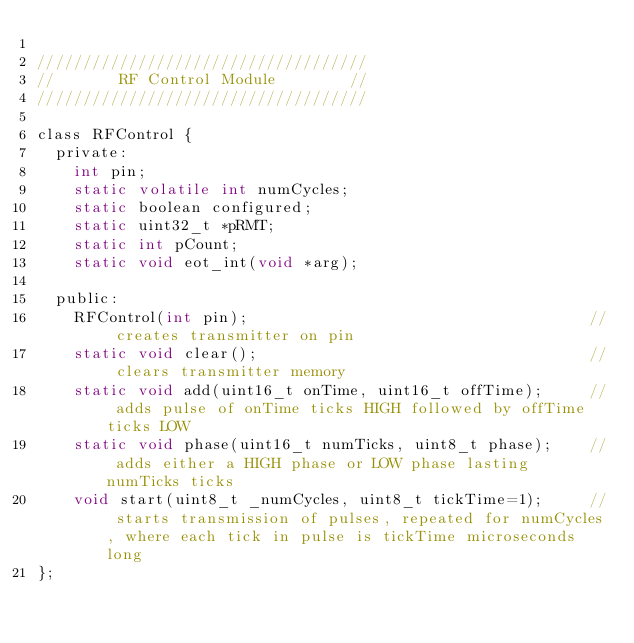<code> <loc_0><loc_0><loc_500><loc_500><_C_>
////////////////////////////////////
//       RF Control Module        //
////////////////////////////////////

class RFControl {
  private:
    int pin;
    static volatile int numCycles;
    static boolean configured;
    static uint32_t *pRMT;
    static int pCount;
    static void eot_int(void *arg);                         

  public:    
    RFControl(int pin);                                     // creates transmitter on pin
    static void clear();                                    // clears transmitter memory
    static void add(uint16_t onTime, uint16_t offTime);     // adds pulse of onTime ticks HIGH followed by offTime ticks LOW
    static void phase(uint16_t numTicks, uint8_t phase);    // adds either a HIGH phase or LOW phase lasting numTicks ticks
    void start(uint8_t _numCycles, uint8_t tickTime=1);     // starts transmission of pulses, repeated for numCycles, where each tick in pulse is tickTime microseconds long
};

   
</code> 